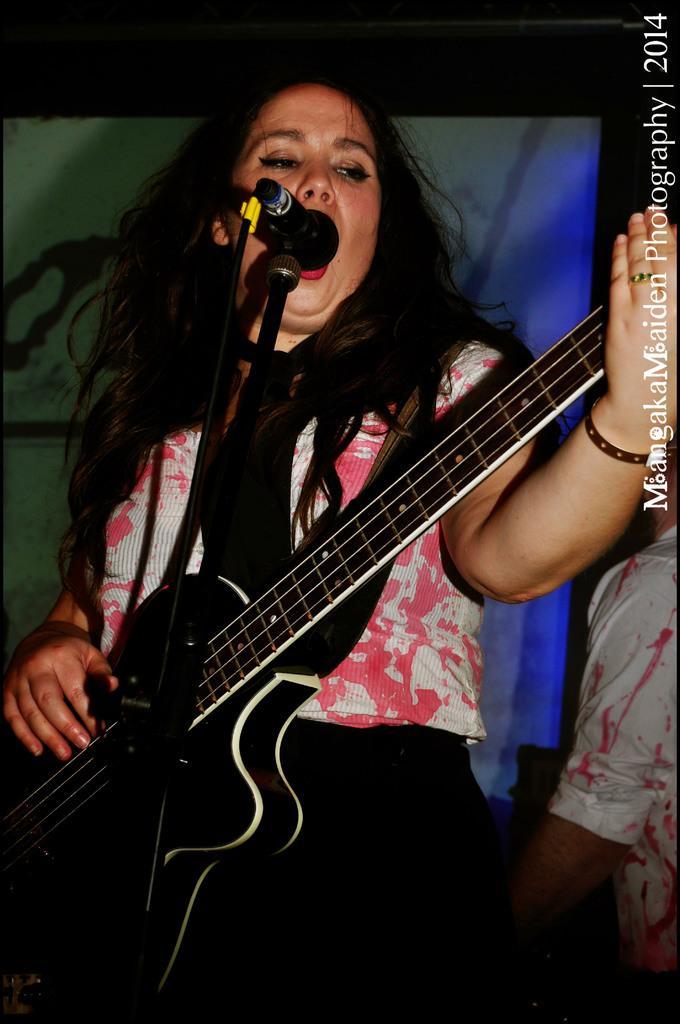Could you give a brief overview of what you see in this image? In this image a lady is playing guitar along with singing. In front of her there is a mic. Behind her there is a poster. In the right a person is standing. 